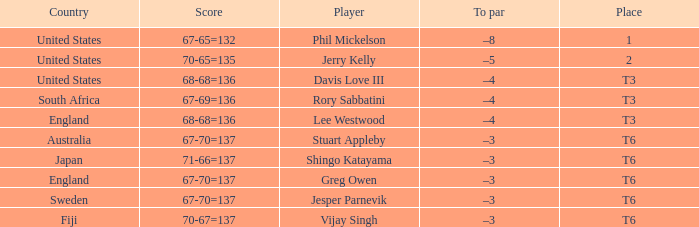Name the score for fiji 70-67=137. 